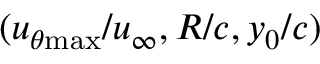Convert formula to latex. <formula><loc_0><loc_0><loc_500><loc_500>( u _ { \theta { \max } } / u _ { \infty } , R / c , y _ { 0 } / c )</formula> 